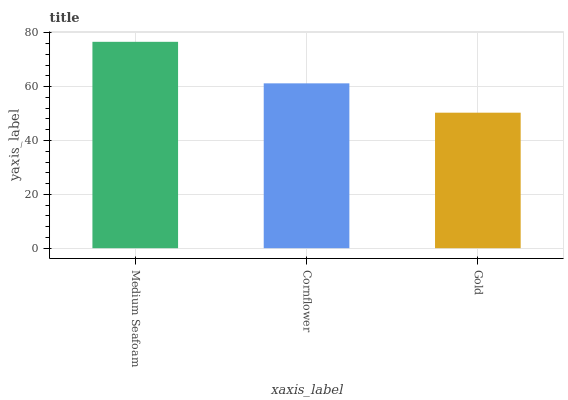Is Cornflower the minimum?
Answer yes or no. No. Is Cornflower the maximum?
Answer yes or no. No. Is Medium Seafoam greater than Cornflower?
Answer yes or no. Yes. Is Cornflower less than Medium Seafoam?
Answer yes or no. Yes. Is Cornflower greater than Medium Seafoam?
Answer yes or no. No. Is Medium Seafoam less than Cornflower?
Answer yes or no. No. Is Cornflower the high median?
Answer yes or no. Yes. Is Cornflower the low median?
Answer yes or no. Yes. Is Medium Seafoam the high median?
Answer yes or no. No. Is Medium Seafoam the low median?
Answer yes or no. No. 